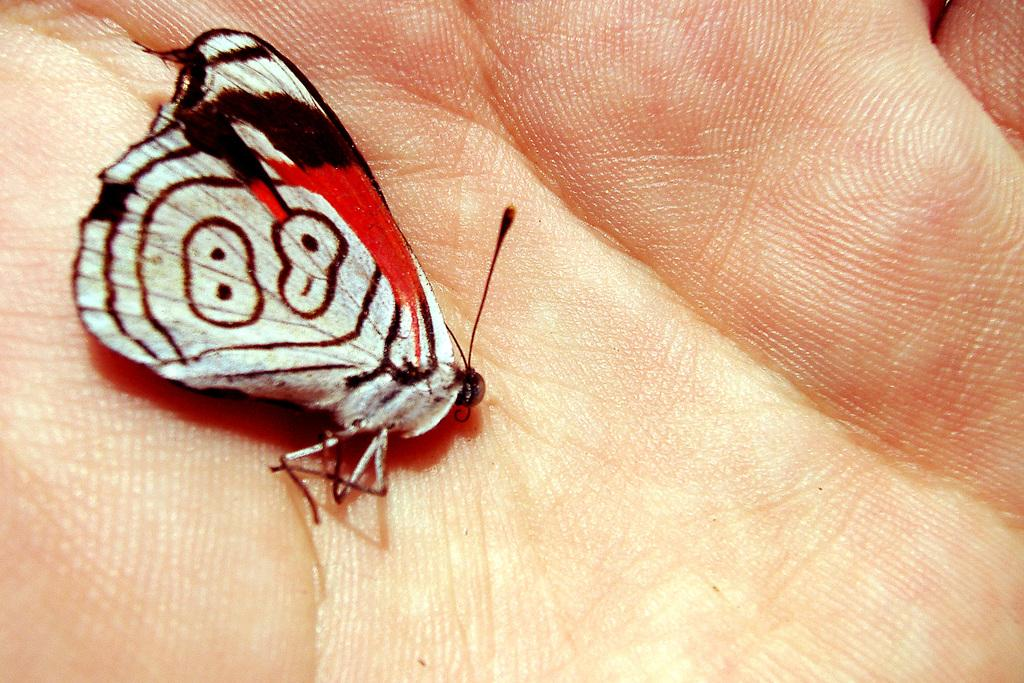What is the main subject of the image? The main subject of the image is a butterfly. Where is the butterfly located in the image? The butterfly is in a person's hand. What type of steel is used to create the acoustics in the image? There is no steel or acoustics present in the image; it features a butterfly in a person's hand. What is the level of love expressed by the butterfly in the image? There is no indication of love or emotion, in the image; it simply shows a butterfly in a person's hand. 